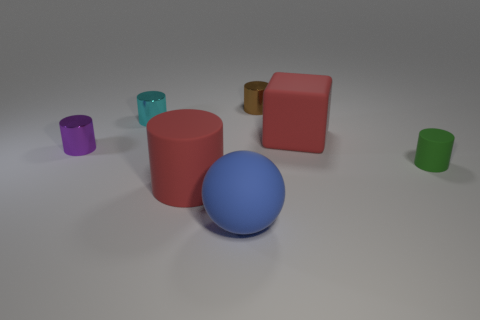Subtract all purple shiny cylinders. How many cylinders are left? 4 Subtract all green cylinders. How many cylinders are left? 4 Add 2 big cyan cubes. How many objects exist? 9 Subtract 3 cylinders. How many cylinders are left? 2 Subtract all cylinders. How many objects are left? 2 Add 1 red rubber objects. How many red rubber objects are left? 3 Add 5 small purple cylinders. How many small purple cylinders exist? 6 Subtract 0 purple cubes. How many objects are left? 7 Subtract all brown spheres. Subtract all cyan cubes. How many spheres are left? 1 Subtract all small purple objects. Subtract all tiny cyan metal things. How many objects are left? 5 